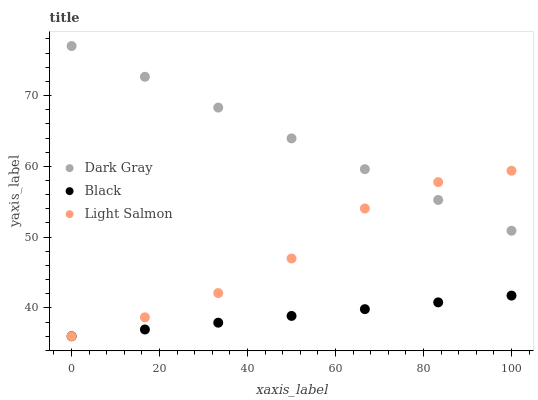Does Black have the minimum area under the curve?
Answer yes or no. Yes. Does Dark Gray have the maximum area under the curve?
Answer yes or no. Yes. Does Light Salmon have the minimum area under the curve?
Answer yes or no. No. Does Light Salmon have the maximum area under the curve?
Answer yes or no. No. Is Dark Gray the smoothest?
Answer yes or no. Yes. Is Light Salmon the roughest?
Answer yes or no. Yes. Is Black the smoothest?
Answer yes or no. No. Is Black the roughest?
Answer yes or no. No. Does Light Salmon have the lowest value?
Answer yes or no. Yes. Does Dark Gray have the highest value?
Answer yes or no. Yes. Does Light Salmon have the highest value?
Answer yes or no. No. Is Black less than Dark Gray?
Answer yes or no. Yes. Is Dark Gray greater than Black?
Answer yes or no. Yes. Does Light Salmon intersect Black?
Answer yes or no. Yes. Is Light Salmon less than Black?
Answer yes or no. No. Is Light Salmon greater than Black?
Answer yes or no. No. Does Black intersect Dark Gray?
Answer yes or no. No. 